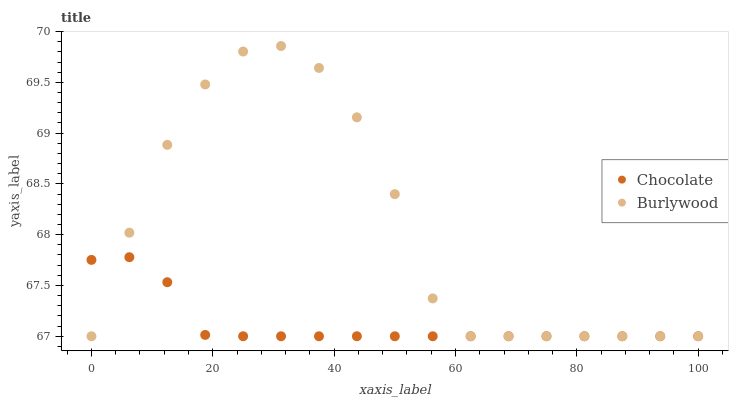Does Chocolate have the minimum area under the curve?
Answer yes or no. Yes. Does Burlywood have the maximum area under the curve?
Answer yes or no. Yes. Does Chocolate have the maximum area under the curve?
Answer yes or no. No. Is Chocolate the smoothest?
Answer yes or no. Yes. Is Burlywood the roughest?
Answer yes or no. Yes. Is Chocolate the roughest?
Answer yes or no. No. Does Burlywood have the lowest value?
Answer yes or no. Yes. Does Burlywood have the highest value?
Answer yes or no. Yes. Does Chocolate have the highest value?
Answer yes or no. No. Does Chocolate intersect Burlywood?
Answer yes or no. Yes. Is Chocolate less than Burlywood?
Answer yes or no. No. Is Chocolate greater than Burlywood?
Answer yes or no. No. 